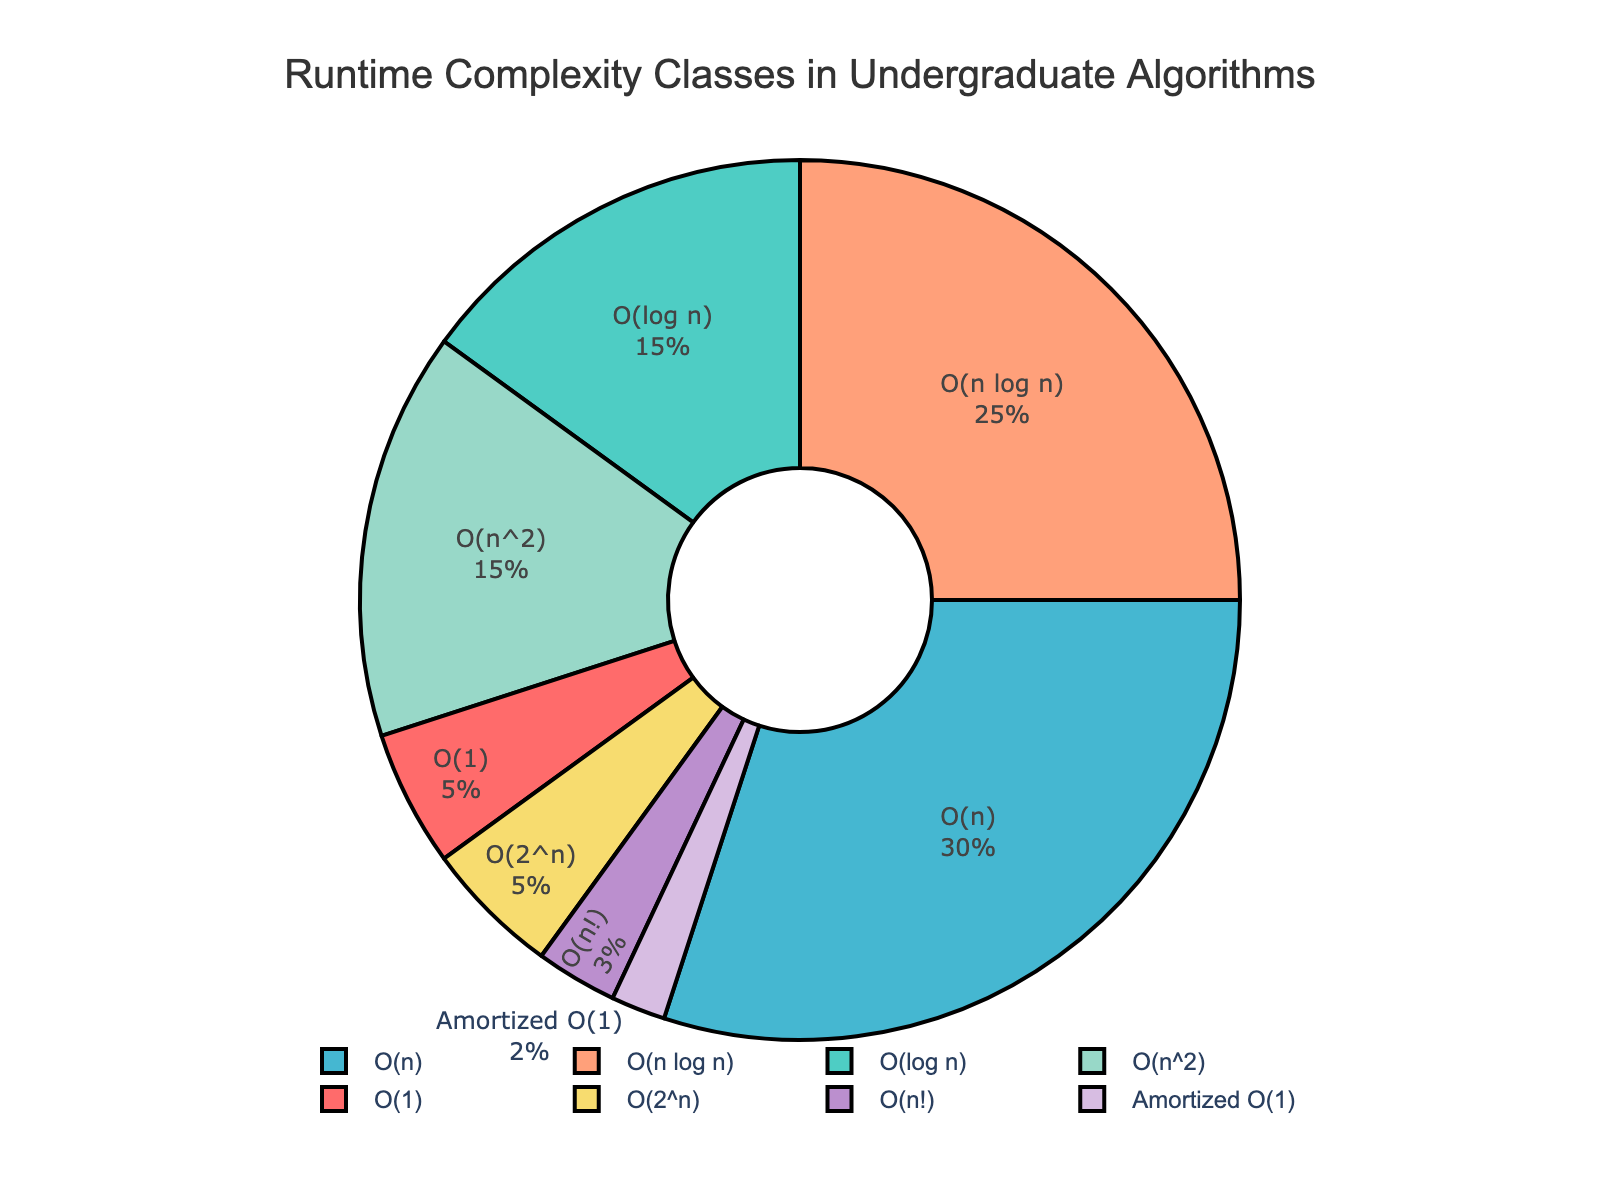What percentage of the algorithms taught has a runtime complexity either logarithmic or linear? First, locate `O(log n)` and `O(n)` classes in the chart. They correspond to 15% and 30% respectively. Sum these percentages: 15% + 30% = 45%.
Answer: 45% Which runtime complexity class has the least representation in the undergraduate courses? Find the smallest percentage in the pie chart. `O(n!)` is 3%, which is the smallest.
Answer: O(n!) How does the representation of `O(n^2)` compare to the sum of `O(2^n)` and `Amortized O(1)`? `O(n^2)` represents 15%. `O(2^n)` is 5% and `Amortized O(1)` is 2%. Sum of `O(2^n)` and `Amortized O(1)` is 5% + 2% = 7%. Therefore, `O(n^2)` is greater than the sum of the other two.
Answer: Greater Which portion of the pie chart is colored blue, and what percentage does it represent? Identify the color blue in the chart. Assuming blue corresponds to `O(n)`, as it's typically third in sequence. It represents 30% of the chart.
Answer: O(n), 30% Is the sum of the percentages of `O(n log n)` and `O(log n)` greater than or less than the percentage of `O(n)`? `O(n log n)` is 25% and `O(log n)` is 15%. Sum these: 25% + 15% = 40%. This is greater than the 30% of `O(n)`.
Answer: Greater Which runtime complexity classes together make up exactly half of the pie chart? Check combinations that add up to 50%. `O(n)` is 30% and `O(n log n)` is 25%. But adding `O(1)` (5%) gets us closer: 30% (O(n)) + 20% (O(n log n)) = 55%. `O(log n)` + `O(n)` + `O(n^2)` = 15% + 30% + 15% = 60%. Only `O(n)` and `O(n log n)` work at 30% + 20% = 55%.
Answer: O(n) and O(n log n) By how much does the percentage of `O(n log n)` exceed that of `O(log n)`? `O(n log n)` is 25% and `O(log n)` is 15%. The difference is 25% - 15% = 10%.
Answer: 10% What color represents the `O(1)` class, and what is its percentage? Identify the segment with `O(1)`. Assuming it's the first color, which is red, and the percentage is 5%.
Answer: Red, 5% 